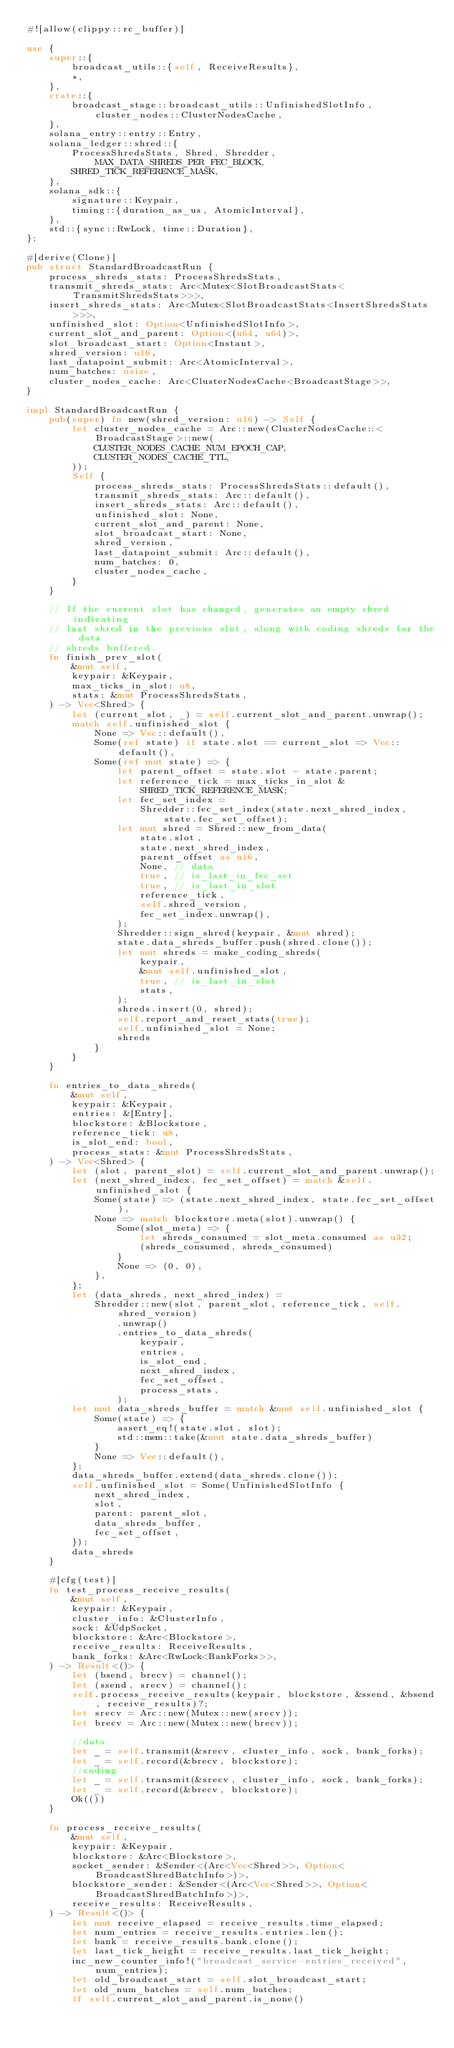<code> <loc_0><loc_0><loc_500><loc_500><_Rust_>#![allow(clippy::rc_buffer)]

use {
    super::{
        broadcast_utils::{self, ReceiveResults},
        *,
    },
    crate::{
        broadcast_stage::broadcast_utils::UnfinishedSlotInfo, cluster_nodes::ClusterNodesCache,
    },
    solana_entry::entry::Entry,
    solana_ledger::shred::{
        ProcessShredsStats, Shred, Shredder, MAX_DATA_SHREDS_PER_FEC_BLOCK,
        SHRED_TICK_REFERENCE_MASK,
    },
    solana_sdk::{
        signature::Keypair,
        timing::{duration_as_us, AtomicInterval},
    },
    std::{sync::RwLock, time::Duration},
};

#[derive(Clone)]
pub struct StandardBroadcastRun {
    process_shreds_stats: ProcessShredsStats,
    transmit_shreds_stats: Arc<Mutex<SlotBroadcastStats<TransmitShredsStats>>>,
    insert_shreds_stats: Arc<Mutex<SlotBroadcastStats<InsertShredsStats>>>,
    unfinished_slot: Option<UnfinishedSlotInfo>,
    current_slot_and_parent: Option<(u64, u64)>,
    slot_broadcast_start: Option<Instant>,
    shred_version: u16,
    last_datapoint_submit: Arc<AtomicInterval>,
    num_batches: usize,
    cluster_nodes_cache: Arc<ClusterNodesCache<BroadcastStage>>,
}

impl StandardBroadcastRun {
    pub(super) fn new(shred_version: u16) -> Self {
        let cluster_nodes_cache = Arc::new(ClusterNodesCache::<BroadcastStage>::new(
            CLUSTER_NODES_CACHE_NUM_EPOCH_CAP,
            CLUSTER_NODES_CACHE_TTL,
        ));
        Self {
            process_shreds_stats: ProcessShredsStats::default(),
            transmit_shreds_stats: Arc::default(),
            insert_shreds_stats: Arc::default(),
            unfinished_slot: None,
            current_slot_and_parent: None,
            slot_broadcast_start: None,
            shred_version,
            last_datapoint_submit: Arc::default(),
            num_batches: 0,
            cluster_nodes_cache,
        }
    }

    // If the current slot has changed, generates an empty shred indicating
    // last shred in the previous slot, along with coding shreds for the data
    // shreds buffered.
    fn finish_prev_slot(
        &mut self,
        keypair: &Keypair,
        max_ticks_in_slot: u8,
        stats: &mut ProcessShredsStats,
    ) -> Vec<Shred> {
        let (current_slot, _) = self.current_slot_and_parent.unwrap();
        match self.unfinished_slot {
            None => Vec::default(),
            Some(ref state) if state.slot == current_slot => Vec::default(),
            Some(ref mut state) => {
                let parent_offset = state.slot - state.parent;
                let reference_tick = max_ticks_in_slot & SHRED_TICK_REFERENCE_MASK;
                let fec_set_index =
                    Shredder::fec_set_index(state.next_shred_index, state.fec_set_offset);
                let mut shred = Shred::new_from_data(
                    state.slot,
                    state.next_shred_index,
                    parent_offset as u16,
                    None, // data
                    true, // is_last_in_fec_set
                    true, // is_last_in_slot
                    reference_tick,
                    self.shred_version,
                    fec_set_index.unwrap(),
                );
                Shredder::sign_shred(keypair, &mut shred);
                state.data_shreds_buffer.push(shred.clone());
                let mut shreds = make_coding_shreds(
                    keypair,
                    &mut self.unfinished_slot,
                    true, // is_last_in_slot
                    stats,
                );
                shreds.insert(0, shred);
                self.report_and_reset_stats(true);
                self.unfinished_slot = None;
                shreds
            }
        }
    }

    fn entries_to_data_shreds(
        &mut self,
        keypair: &Keypair,
        entries: &[Entry],
        blockstore: &Blockstore,
        reference_tick: u8,
        is_slot_end: bool,
        process_stats: &mut ProcessShredsStats,
    ) -> Vec<Shred> {
        let (slot, parent_slot) = self.current_slot_and_parent.unwrap();
        let (next_shred_index, fec_set_offset) = match &self.unfinished_slot {
            Some(state) => (state.next_shred_index, state.fec_set_offset),
            None => match blockstore.meta(slot).unwrap() {
                Some(slot_meta) => {
                    let shreds_consumed = slot_meta.consumed as u32;
                    (shreds_consumed, shreds_consumed)
                }
                None => (0, 0),
            },
        };
        let (data_shreds, next_shred_index) =
            Shredder::new(slot, parent_slot, reference_tick, self.shred_version)
                .unwrap()
                .entries_to_data_shreds(
                    keypair,
                    entries,
                    is_slot_end,
                    next_shred_index,
                    fec_set_offset,
                    process_stats,
                );
        let mut data_shreds_buffer = match &mut self.unfinished_slot {
            Some(state) => {
                assert_eq!(state.slot, slot);
                std::mem::take(&mut state.data_shreds_buffer)
            }
            None => Vec::default(),
        };
        data_shreds_buffer.extend(data_shreds.clone());
        self.unfinished_slot = Some(UnfinishedSlotInfo {
            next_shred_index,
            slot,
            parent: parent_slot,
            data_shreds_buffer,
            fec_set_offset,
        });
        data_shreds
    }

    #[cfg(test)]
    fn test_process_receive_results(
        &mut self,
        keypair: &Keypair,
        cluster_info: &ClusterInfo,
        sock: &UdpSocket,
        blockstore: &Arc<Blockstore>,
        receive_results: ReceiveResults,
        bank_forks: &Arc<RwLock<BankForks>>,
    ) -> Result<()> {
        let (bsend, brecv) = channel();
        let (ssend, srecv) = channel();
        self.process_receive_results(keypair, blockstore, &ssend, &bsend, receive_results)?;
        let srecv = Arc::new(Mutex::new(srecv));
        let brecv = Arc::new(Mutex::new(brecv));

        //data
        let _ = self.transmit(&srecv, cluster_info, sock, bank_forks);
        let _ = self.record(&brecv, blockstore);
        //coding
        let _ = self.transmit(&srecv, cluster_info, sock, bank_forks);
        let _ = self.record(&brecv, blockstore);
        Ok(())
    }

    fn process_receive_results(
        &mut self,
        keypair: &Keypair,
        blockstore: &Arc<Blockstore>,
        socket_sender: &Sender<(Arc<Vec<Shred>>, Option<BroadcastShredBatchInfo>)>,
        blockstore_sender: &Sender<(Arc<Vec<Shred>>, Option<BroadcastShredBatchInfo>)>,
        receive_results: ReceiveResults,
    ) -> Result<()> {
        let mut receive_elapsed = receive_results.time_elapsed;
        let num_entries = receive_results.entries.len();
        let bank = receive_results.bank.clone();
        let last_tick_height = receive_results.last_tick_height;
        inc_new_counter_info!("broadcast_service-entries_received", num_entries);
        let old_broadcast_start = self.slot_broadcast_start;
        let old_num_batches = self.num_batches;
        if self.current_slot_and_parent.is_none()</code> 